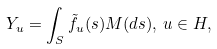Convert formula to latex. <formula><loc_0><loc_0><loc_500><loc_500>Y _ { u } = \int _ { S } \tilde { f } _ { u } ( s ) M ( d s ) , \, u \in H ,</formula> 